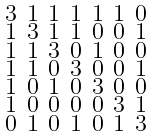Convert formula to latex. <formula><loc_0><loc_0><loc_500><loc_500>\begin{smallmatrix} 3 & 1 & 1 & 1 & 1 & 1 & 0 \\ 1 & 3 & 1 & 1 & 0 & 0 & 1 \\ 1 & 1 & 3 & 0 & 1 & 0 & 0 \\ 1 & 1 & 0 & 3 & 0 & 0 & 1 \\ 1 & 0 & 1 & 0 & 3 & 0 & 0 \\ 1 & 0 & 0 & 0 & 0 & 3 & 1 \\ 0 & 1 & 0 & 1 & 0 & 1 & 3 \end{smallmatrix}</formula> 